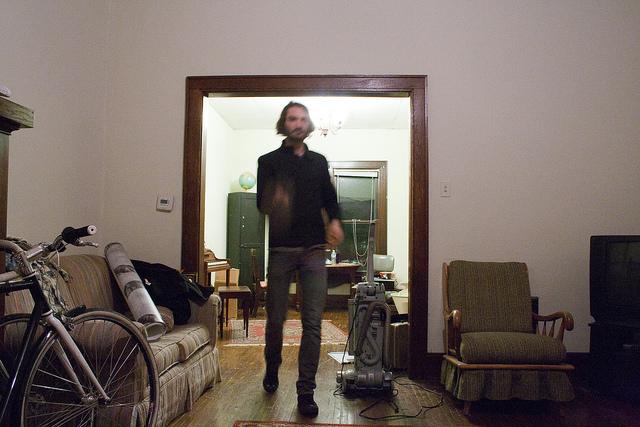How many seats?
Be succinct. 3. Is the furniture modern?
Write a very short answer. No. Why is the person blurry?
Short answer required. He is moving. 